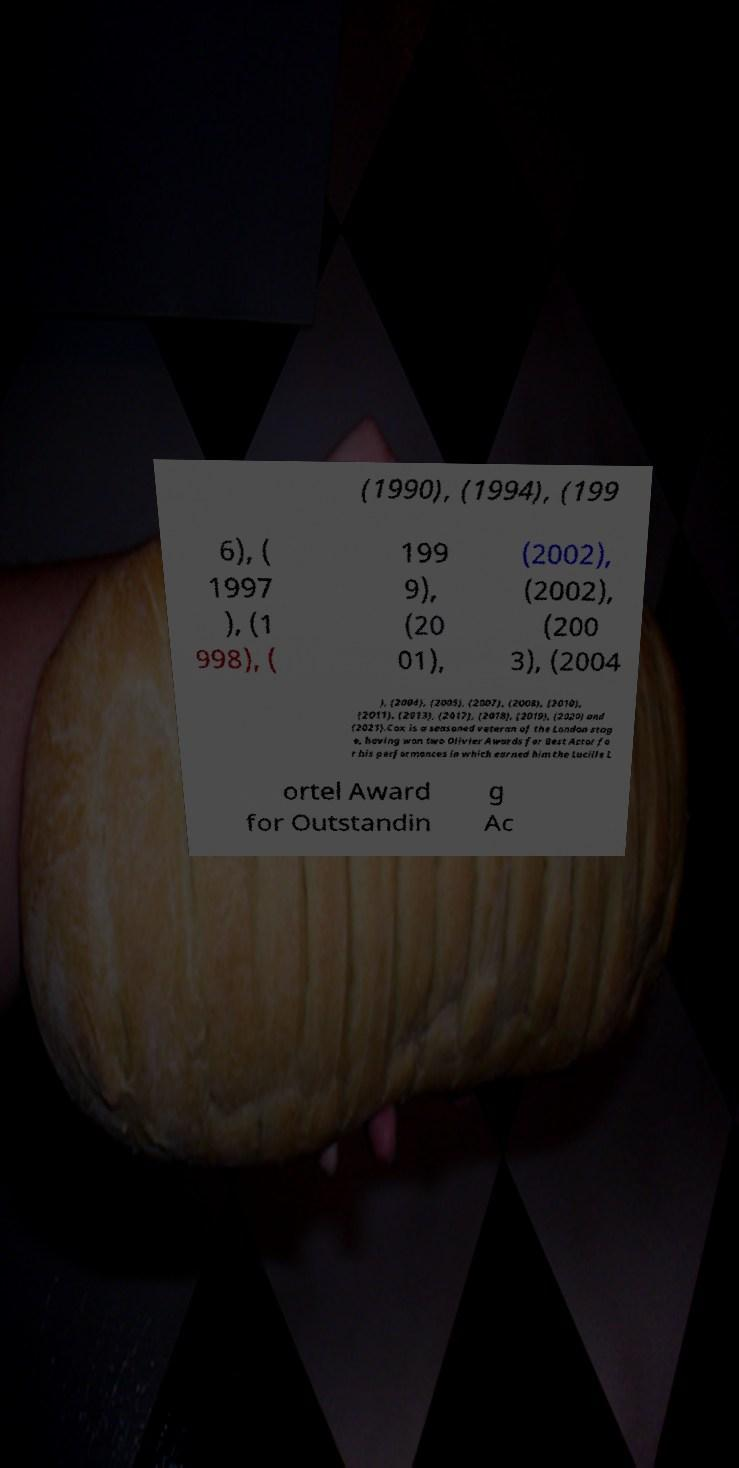Please read and relay the text visible in this image. What does it say? (1990), (1994), (199 6), ( 1997 ), (1 998), ( 199 9), (20 01), (2002), (2002), (200 3), (2004 ), (2004), (2005), (2007), (2008), (2010), (2011), (2013), (2017), (2018), (2019), (2020) and (2021).Cox is a seasoned veteran of the London stag e, having won two Olivier Awards for Best Actor fo r his performances in which earned him the Lucille L ortel Award for Outstandin g Ac 